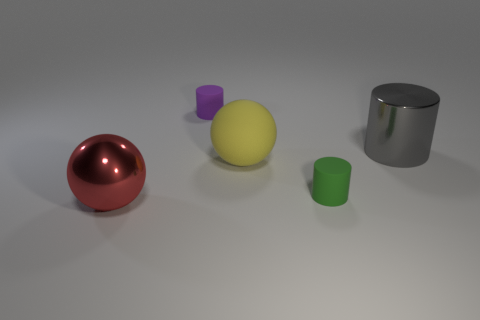What could be the possible uses for these objects in practical scenarios? These objects can have versatile uses depending on their properties. The red rubber ball could be used for play, such as in children's sports. The yellow plastic ball might serve as a light, durable option for various indoor games. The cylinders, especially if they are sturdy and metallic like the blue one, could be used as containers or for storing materials in workshops or labs due to their robust build. 